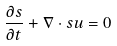Convert formula to latex. <formula><loc_0><loc_0><loc_500><loc_500>\frac { \partial s } { \partial t } + \nabla \cdot s { u } = 0</formula> 